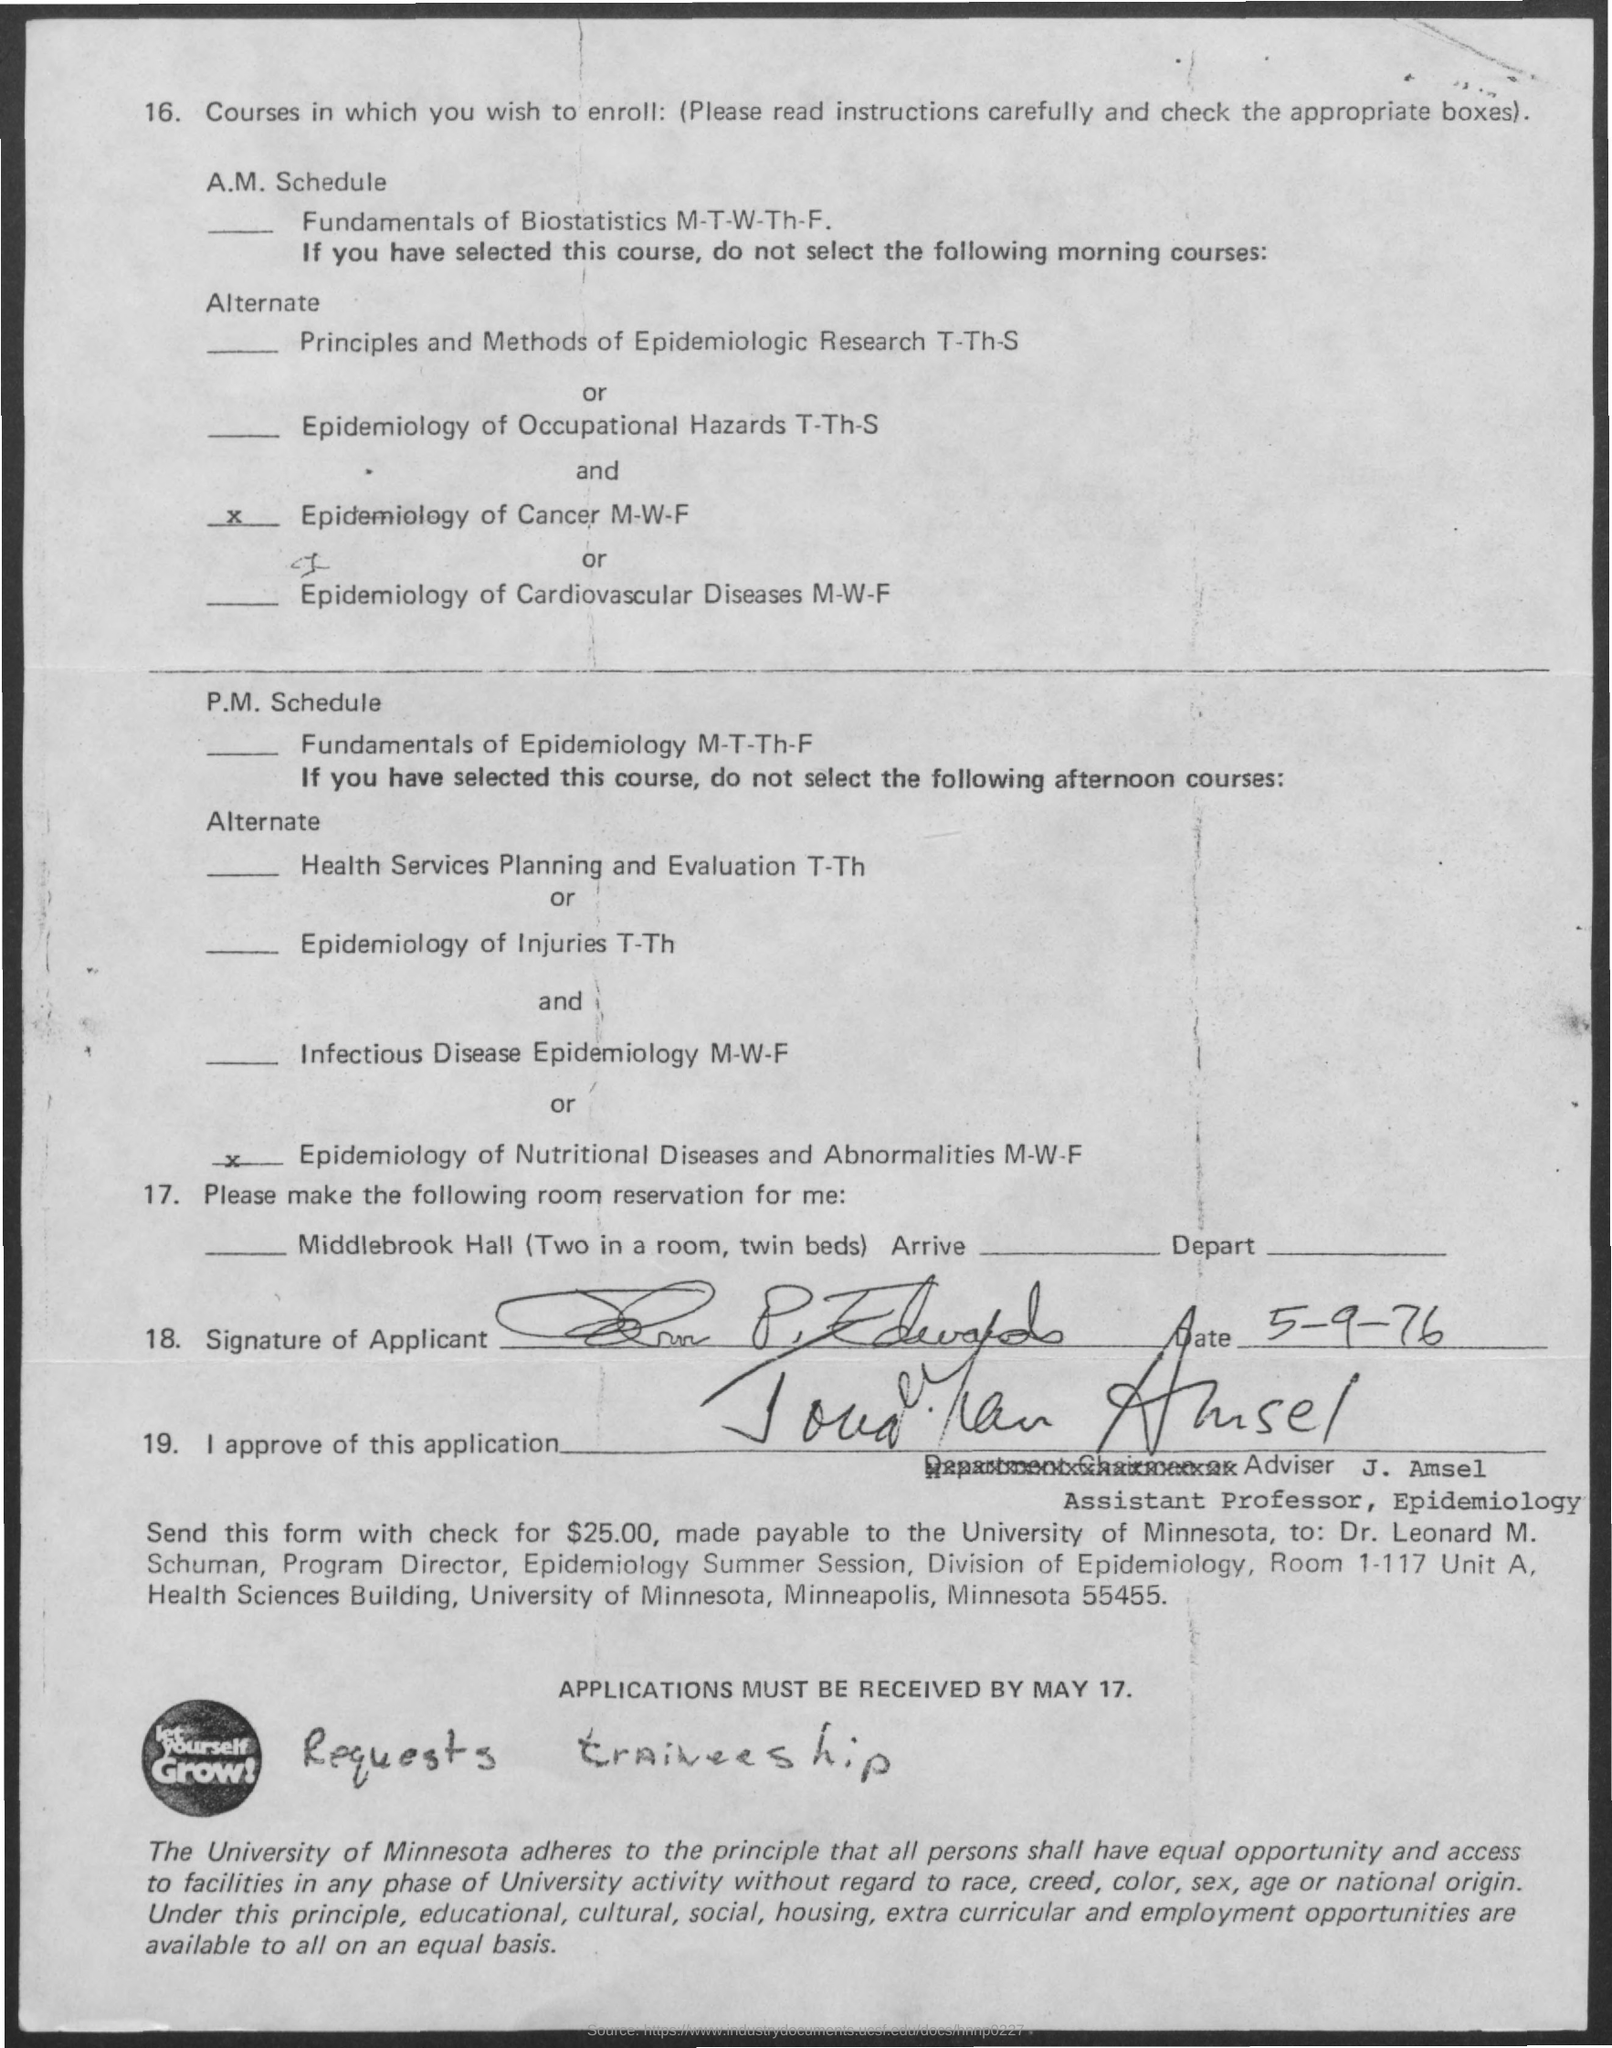Draw attention to some important aspects in this diagram. The date on the document is 5-9-76," the witness declared. 